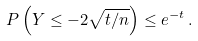Convert formula to latex. <formula><loc_0><loc_0><loc_500><loc_500>P \left ( Y \leq - 2 \sqrt { t / n } \right ) \leq e ^ { - t } \, .</formula> 